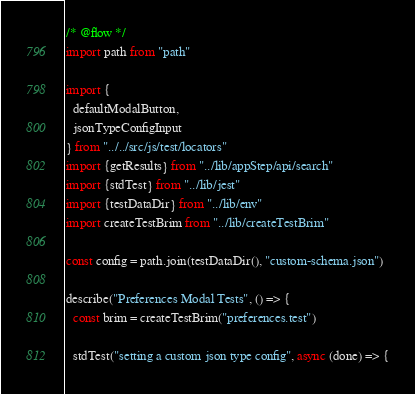<code> <loc_0><loc_0><loc_500><loc_500><_JavaScript_>/* @flow */
import path from "path"

import {
  defaultModalButton,
  jsonTypeConfigInput
} from "../../src/js/test/locators"
import {getResults} from "../lib/appStep/api/search"
import {stdTest} from "../lib/jest"
import {testDataDir} from "../lib/env"
import createTestBrim from "../lib/createTestBrim"

const config = path.join(testDataDir(), "custom-schema.json")

describe("Preferences Modal Tests", () => {
  const brim = createTestBrim("preferences.test")

  stdTest("setting a custom json type config", async (done) => {</code> 